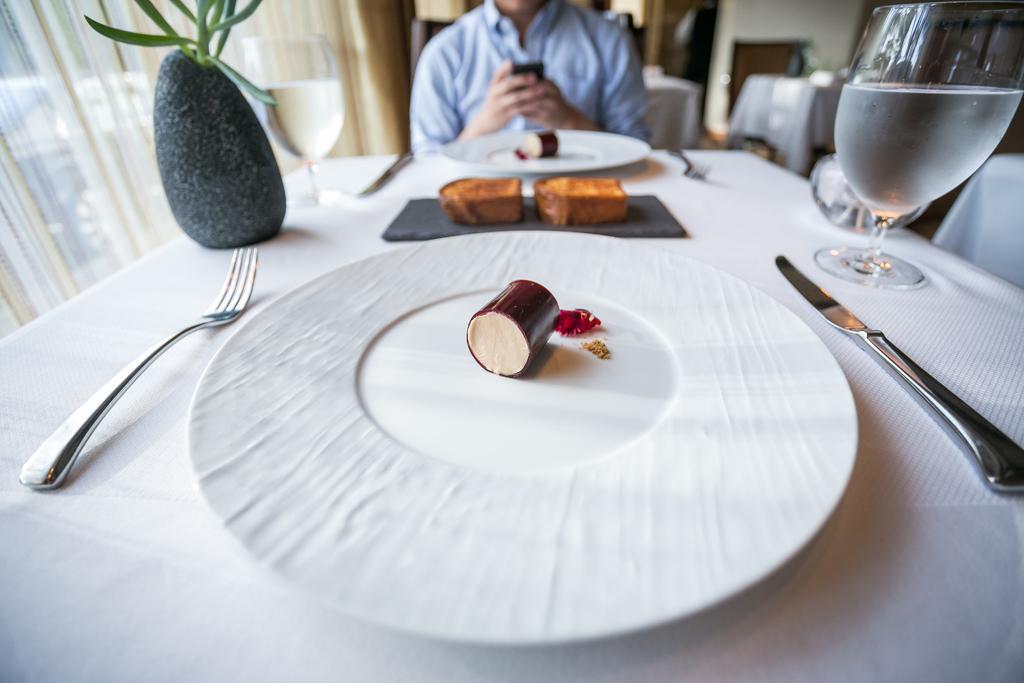In one or two sentences, can you explain what this image depicts? Person sitting on the chair and on the table we have plate,folk,plant,glass,food. 